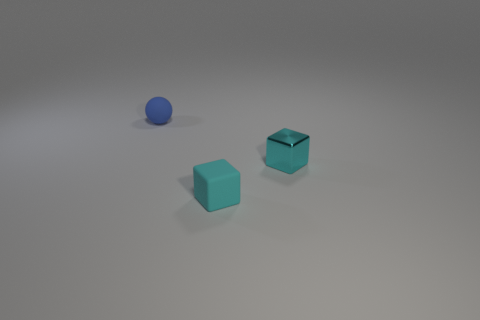Add 1 cyan metal blocks. How many objects exist? 4 Subtract all blocks. How many objects are left? 1 Subtract 0 purple cylinders. How many objects are left? 3 Subtract all purple metal spheres. Subtract all matte cubes. How many objects are left? 2 Add 3 tiny blue spheres. How many tiny blue spheres are left? 4 Add 2 rubber blocks. How many rubber blocks exist? 3 